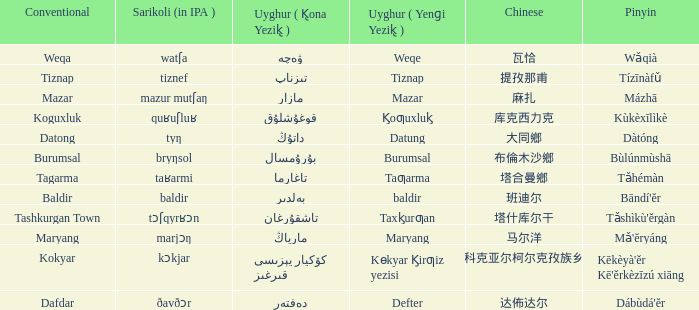Would you be able to parse every entry in this table? {'header': ['Conventional', 'Sarikoli (in IPA )', 'Uyghur ( K̢ona Yezik̢ )', 'Uyghur ( Yenɡi Yezik̢ )', 'Chinese', 'Pinyin'], 'rows': [['Weqa', 'watʃa', 'ۋەچە', 'Weqe', '瓦恰', 'Wǎqià'], ['Tiznap', 'tiznef', 'تىزناپ', 'Tiznap', '提孜那甫', 'Tízīnàfǔ'], ['Mazar', 'mazur mutʃaŋ', 'مازار', 'Mazar', '麻扎', 'Mázhā'], ['Koguxluk', 'quʁuʃluʁ', 'قوغۇشلۇق', 'K̡oƣuxluk̡', '库克西力克', 'Kùkèxīlìkè'], ['Datong', 'tyŋ', 'داتۇڭ', 'Datung', '大同鄉', 'Dàtóng'], ['Burumsal', 'bryŋsol', 'بۇرۇمسال', 'Burumsal', '布倫木沙鄉', 'Bùlúnmùshā'], ['Tagarma', 'taʁarmi', 'تاغارما', 'Taƣarma', '塔合曼鄉', 'Tǎhémàn'], ['Baldir', 'baldir', 'بەلدىر', 'baldir', '班迪尔', "Bāndí'ĕr"], ['Tashkurgan Town', 'tɔʃqyrʁɔn', 'تاشقۇرغان', 'Taxk̡urƣan', '塔什库尔干', "Tǎshìkù'ěrgàn"], ['Maryang', 'marjɔŋ', 'مارياڭ', 'Maryang', '马尔洋', "Mǎ'ĕryáng"], ['Kokyar', 'kɔkjar', 'كۆكيار قىرغىز يېزىسى', 'Kɵkyar K̡irƣiz yezisi', '科克亚尔柯尔克孜族乡', "Kēkèyà'ěr Kē'ěrkèzīzú xiāng"], ['Dafdar', 'ðavðɔr', 'دەفتەر', 'Defter', '达佈达尔', "Dábùdá'ĕr"]]} Name the uyghur for  瓦恰 ۋەچە. 